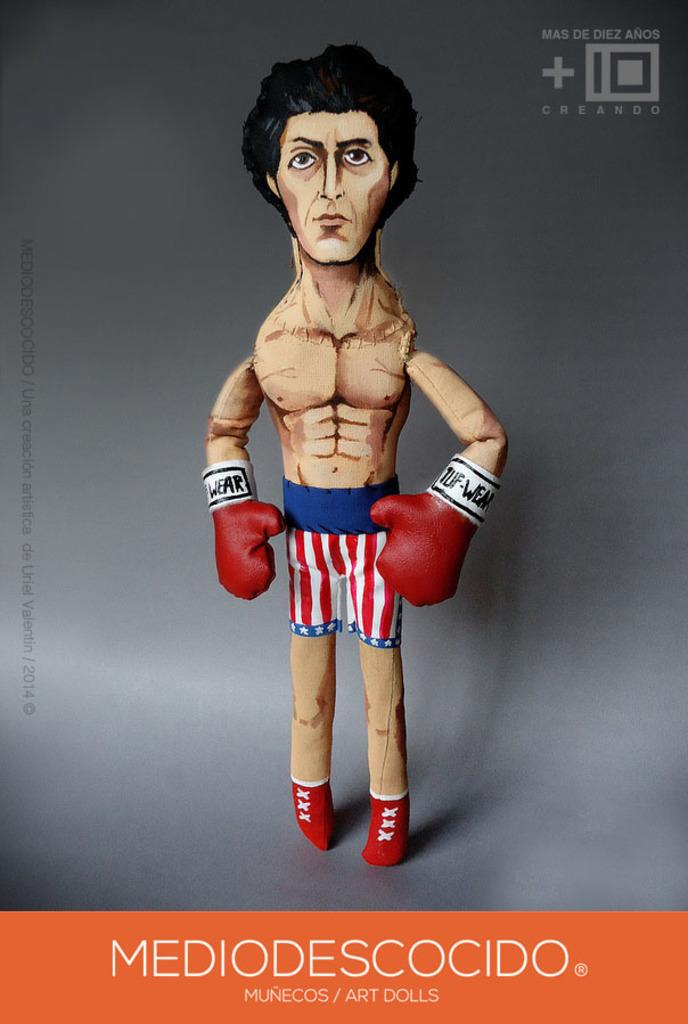<image>
Describe the image concisely. A drawing of a boxer has art dolls at the bottom of the sign. 